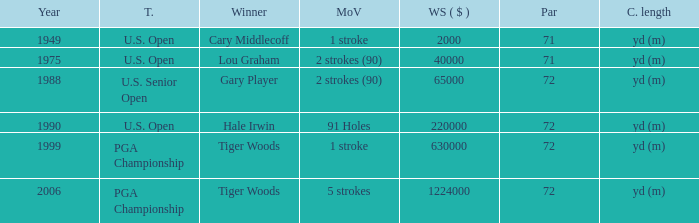When hale irwin is the winner what is the margin of victory? 91 Holes. 